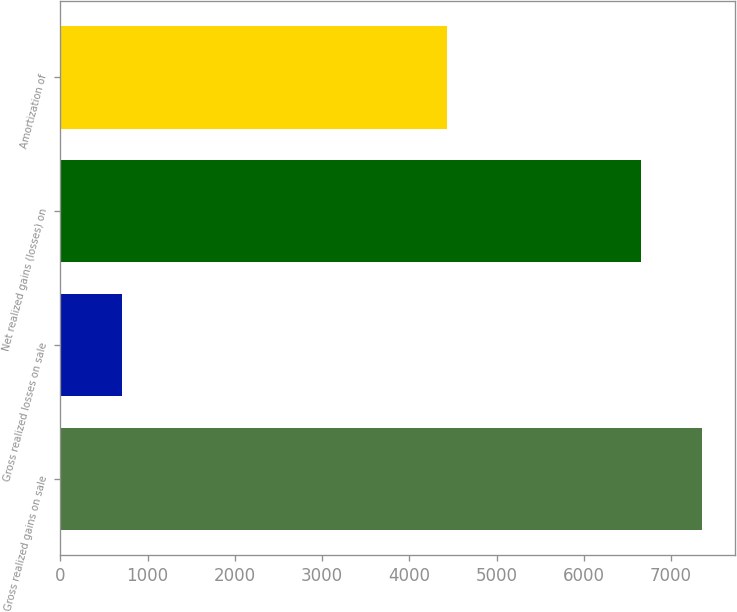Convert chart. <chart><loc_0><loc_0><loc_500><loc_500><bar_chart><fcel>Gross realized gains on sale<fcel>Gross realized losses on sale<fcel>Net realized gains (losses) on<fcel>Amortization of<nl><fcel>7360<fcel>710<fcel>6650<fcel>4427<nl></chart> 